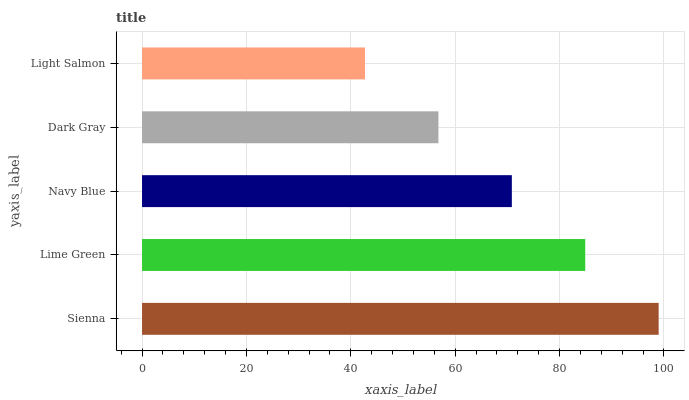Is Light Salmon the minimum?
Answer yes or no. Yes. Is Sienna the maximum?
Answer yes or no. Yes. Is Lime Green the minimum?
Answer yes or no. No. Is Lime Green the maximum?
Answer yes or no. No. Is Sienna greater than Lime Green?
Answer yes or no. Yes. Is Lime Green less than Sienna?
Answer yes or no. Yes. Is Lime Green greater than Sienna?
Answer yes or no. No. Is Sienna less than Lime Green?
Answer yes or no. No. Is Navy Blue the high median?
Answer yes or no. Yes. Is Navy Blue the low median?
Answer yes or no. Yes. Is Light Salmon the high median?
Answer yes or no. No. Is Light Salmon the low median?
Answer yes or no. No. 